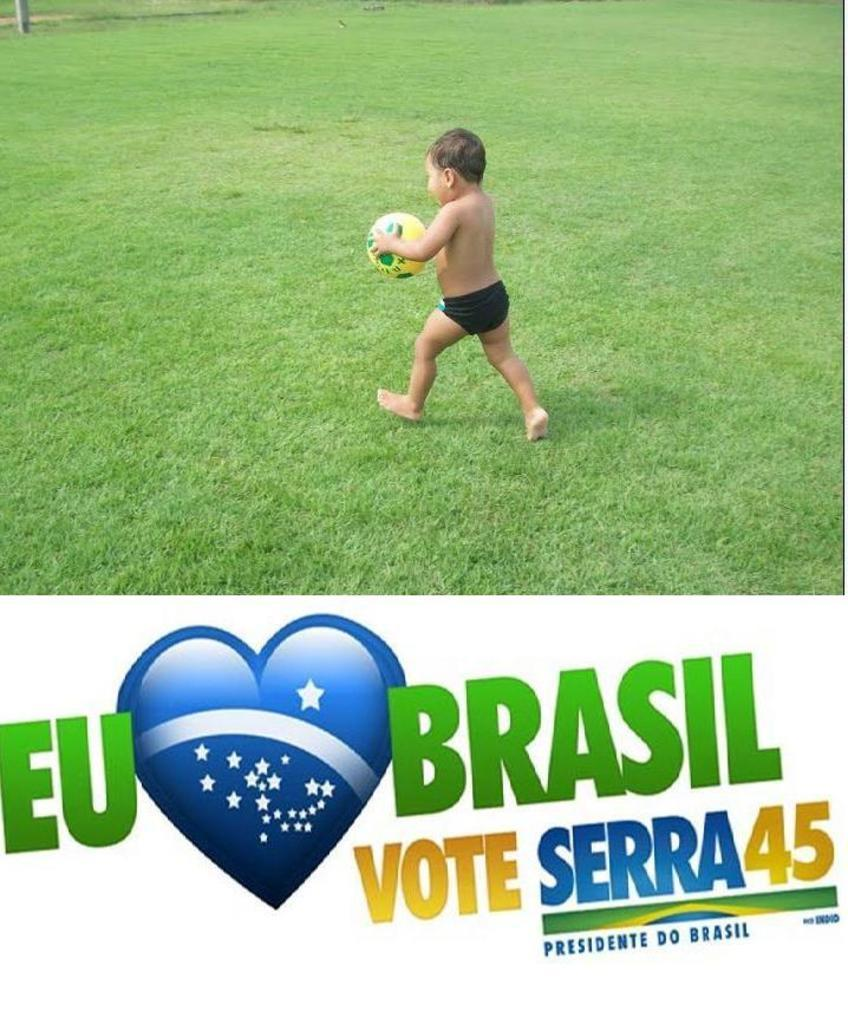What is the main subject of the image? The main subject of the image is a kid. What is the kid holding in the image? The kid is holding a ball. What type of surface is visible in the image? There is grass visible in the image. What can be found at the bottom of the image? There is text at the bottom of the image. What type of tin can be seen in the image? There is no tin present in the image. What is the range of the ball being thrown by the kid in the image? The image does not show the ball being thrown, so it is impossible to determine its range. 